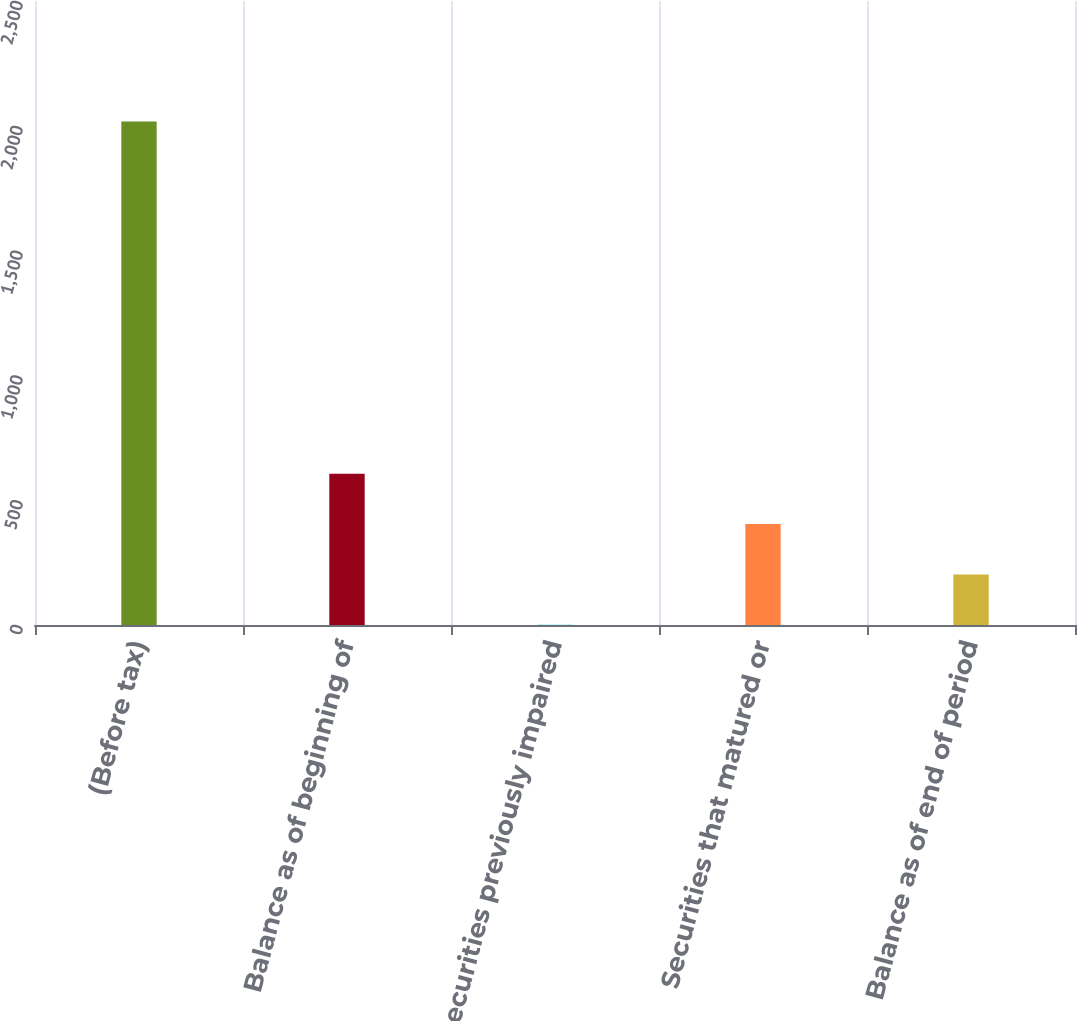Convert chart to OTSL. <chart><loc_0><loc_0><loc_500><loc_500><bar_chart><fcel>(Before tax)<fcel>Balance as of beginning of<fcel>Securities previously impaired<fcel>Securities that matured or<fcel>Balance as of end of period<nl><fcel>2017<fcel>605.8<fcel>1<fcel>404.2<fcel>202.6<nl></chart> 